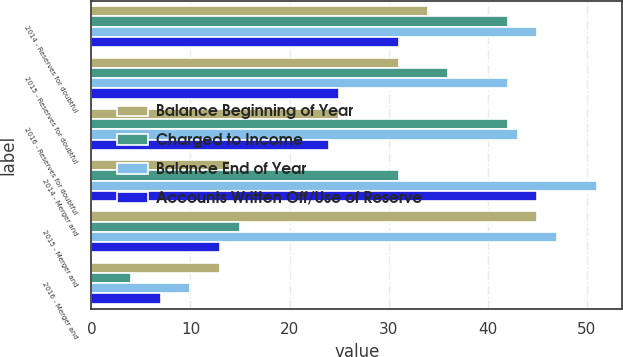<chart> <loc_0><loc_0><loc_500><loc_500><stacked_bar_chart><ecel><fcel>2014 - Reserves for doubtful<fcel>2015 - Reserves for doubtful<fcel>2016 - Reserves for doubtful<fcel>2014 - Merger and<fcel>2015 - Merger and<fcel>2016 - Merger and<nl><fcel>Balance Beginning of Year<fcel>34<fcel>31<fcel>25<fcel>14<fcel>45<fcel>13<nl><fcel>Charged to Income<fcel>42<fcel>36<fcel>42<fcel>31<fcel>15<fcel>4<nl><fcel>Balance End of Year<fcel>45<fcel>42<fcel>43<fcel>51<fcel>47<fcel>10<nl><fcel>Accounts Written Off/Use of Reserve<fcel>31<fcel>25<fcel>24<fcel>45<fcel>13<fcel>7<nl></chart> 